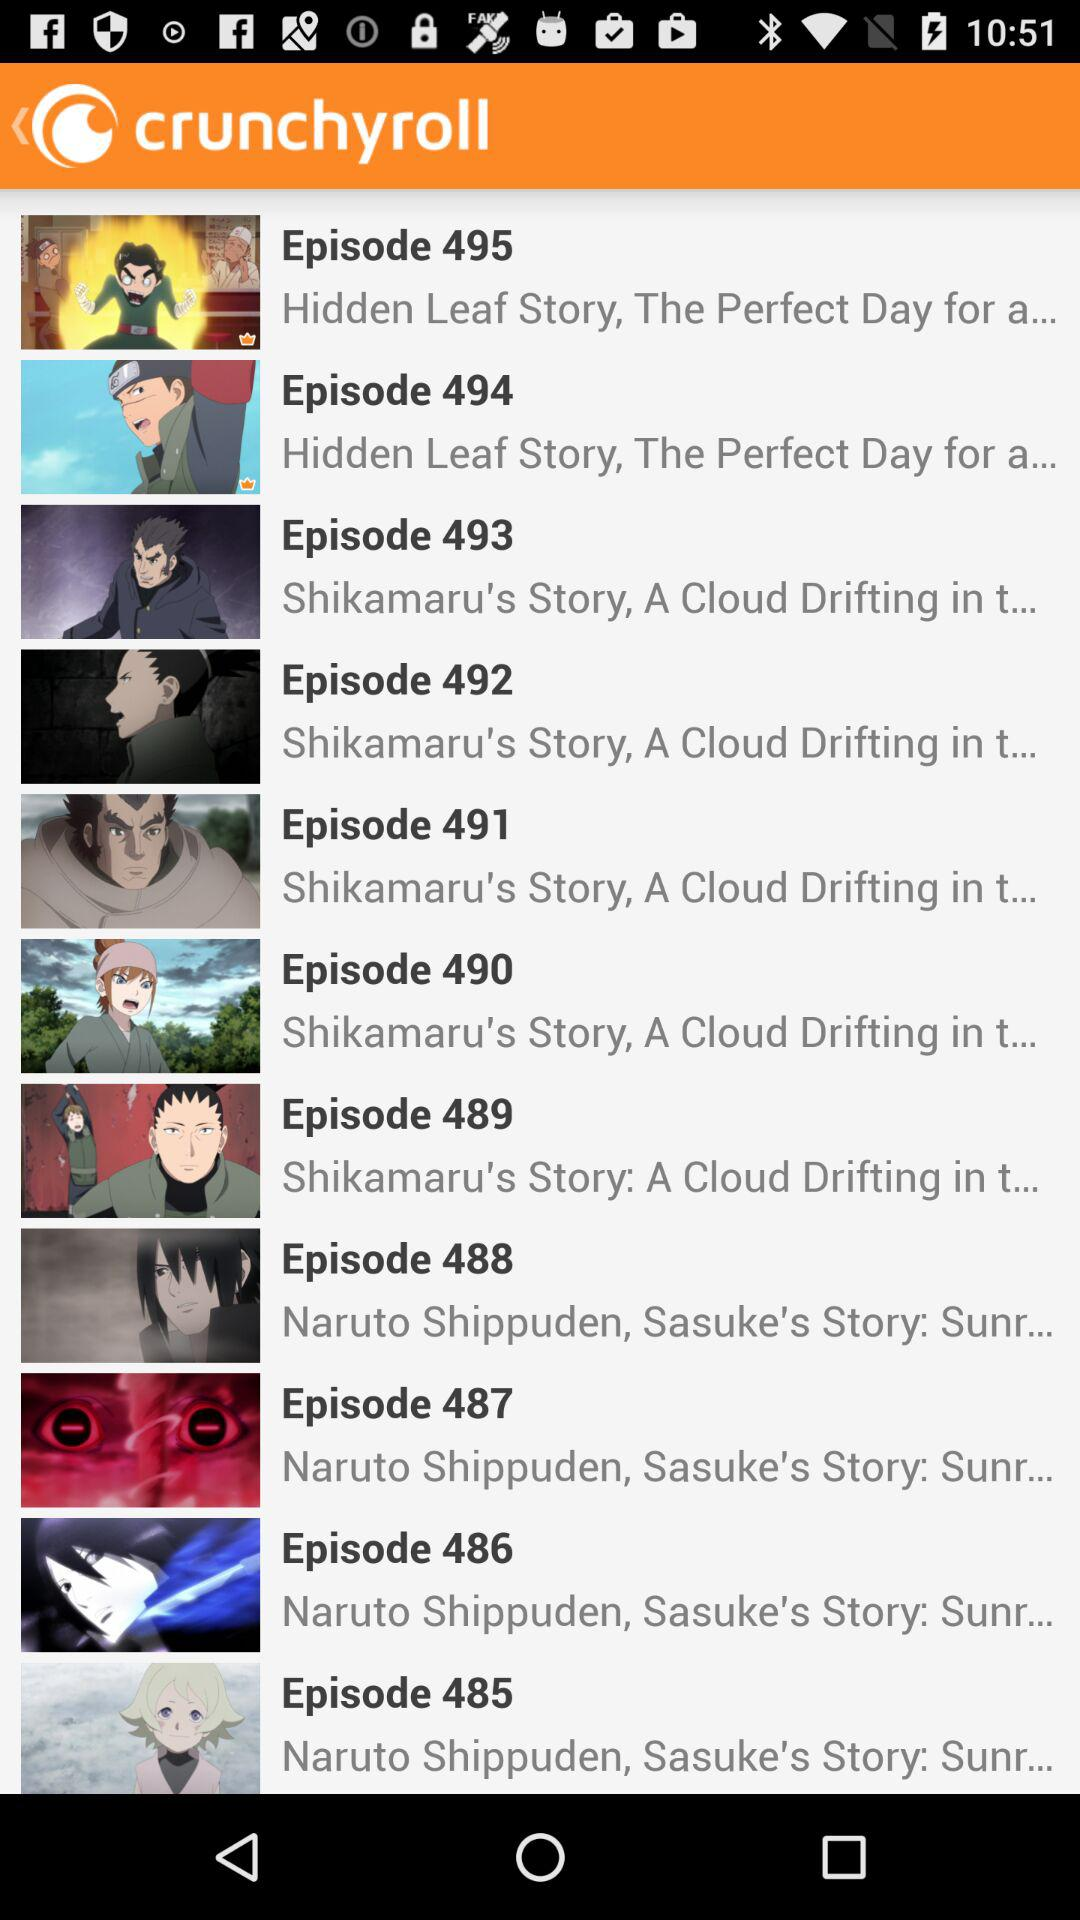What is the episode name of the episode 495? The episode name is "Hidden Leaf Story, The Perfect Day for a...". 